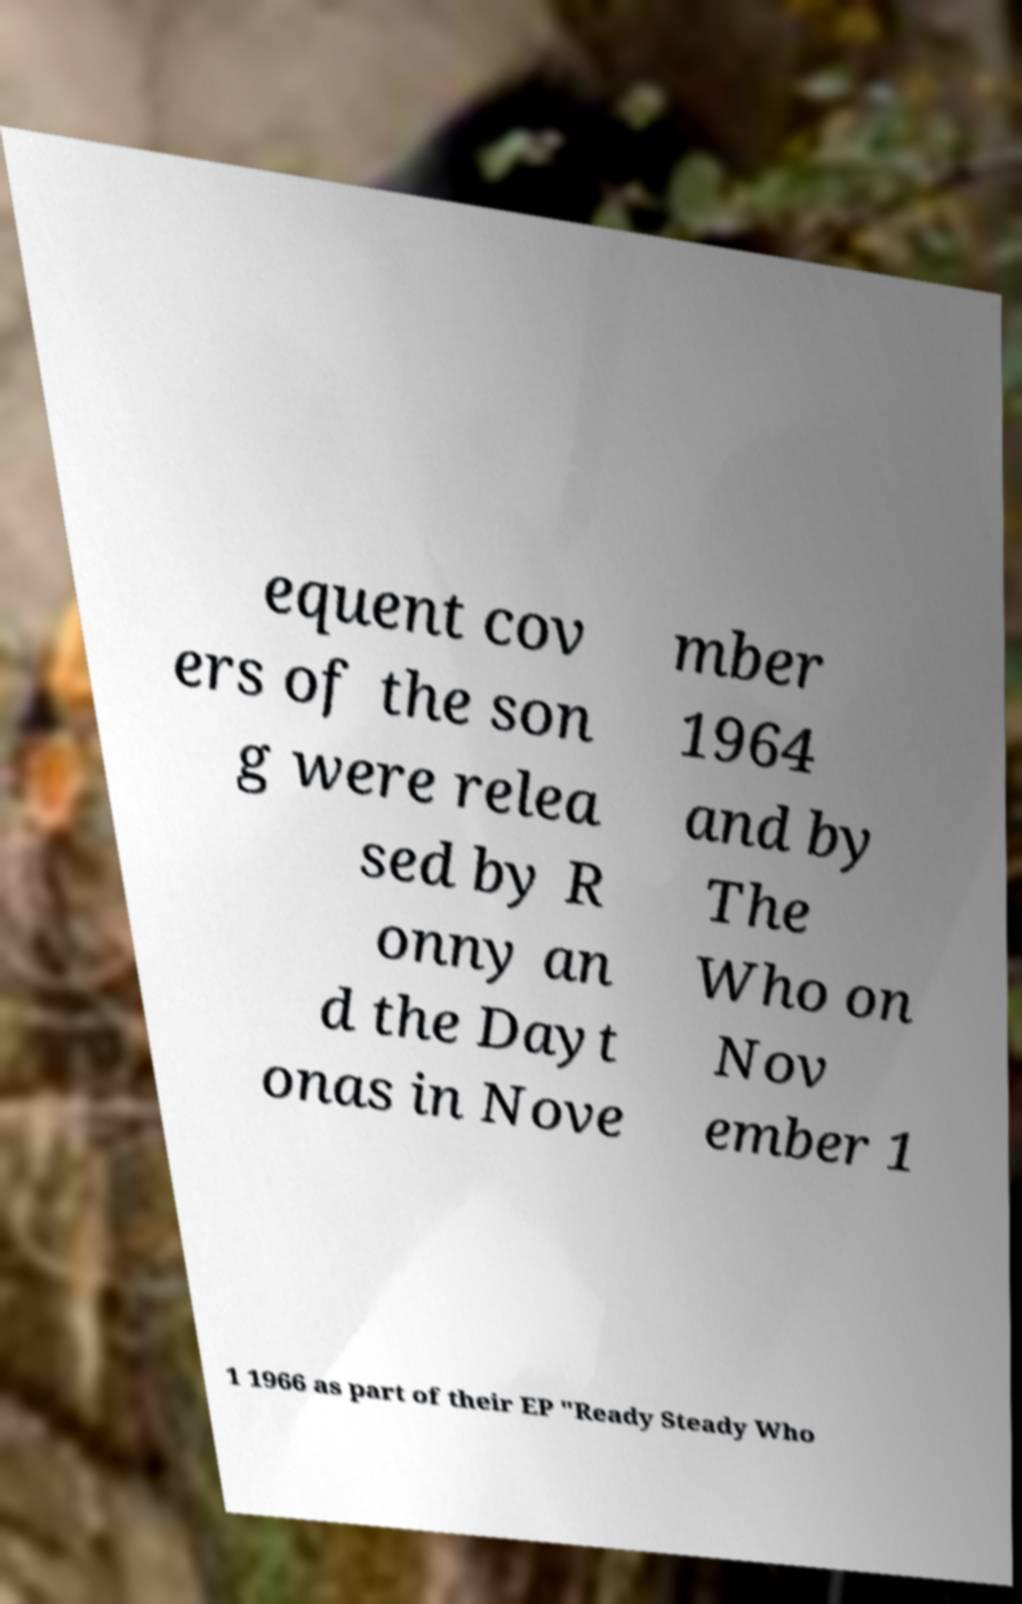There's text embedded in this image that I need extracted. Can you transcribe it verbatim? equent cov ers of the son g were relea sed by R onny an d the Dayt onas in Nove mber 1964 and by The Who on Nov ember 1 1 1966 as part of their EP "Ready Steady Who 